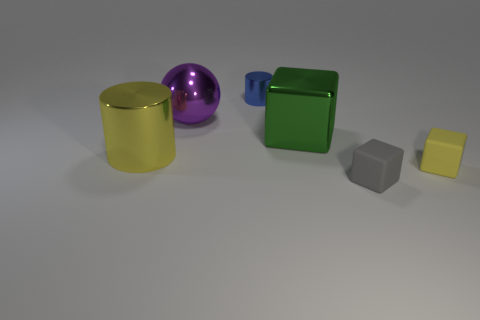Are there any blue cylinders behind the yellow matte block? Yes, there is one blue cylinder located behind the yellow matte block towards the left, slightly obscured from view. 